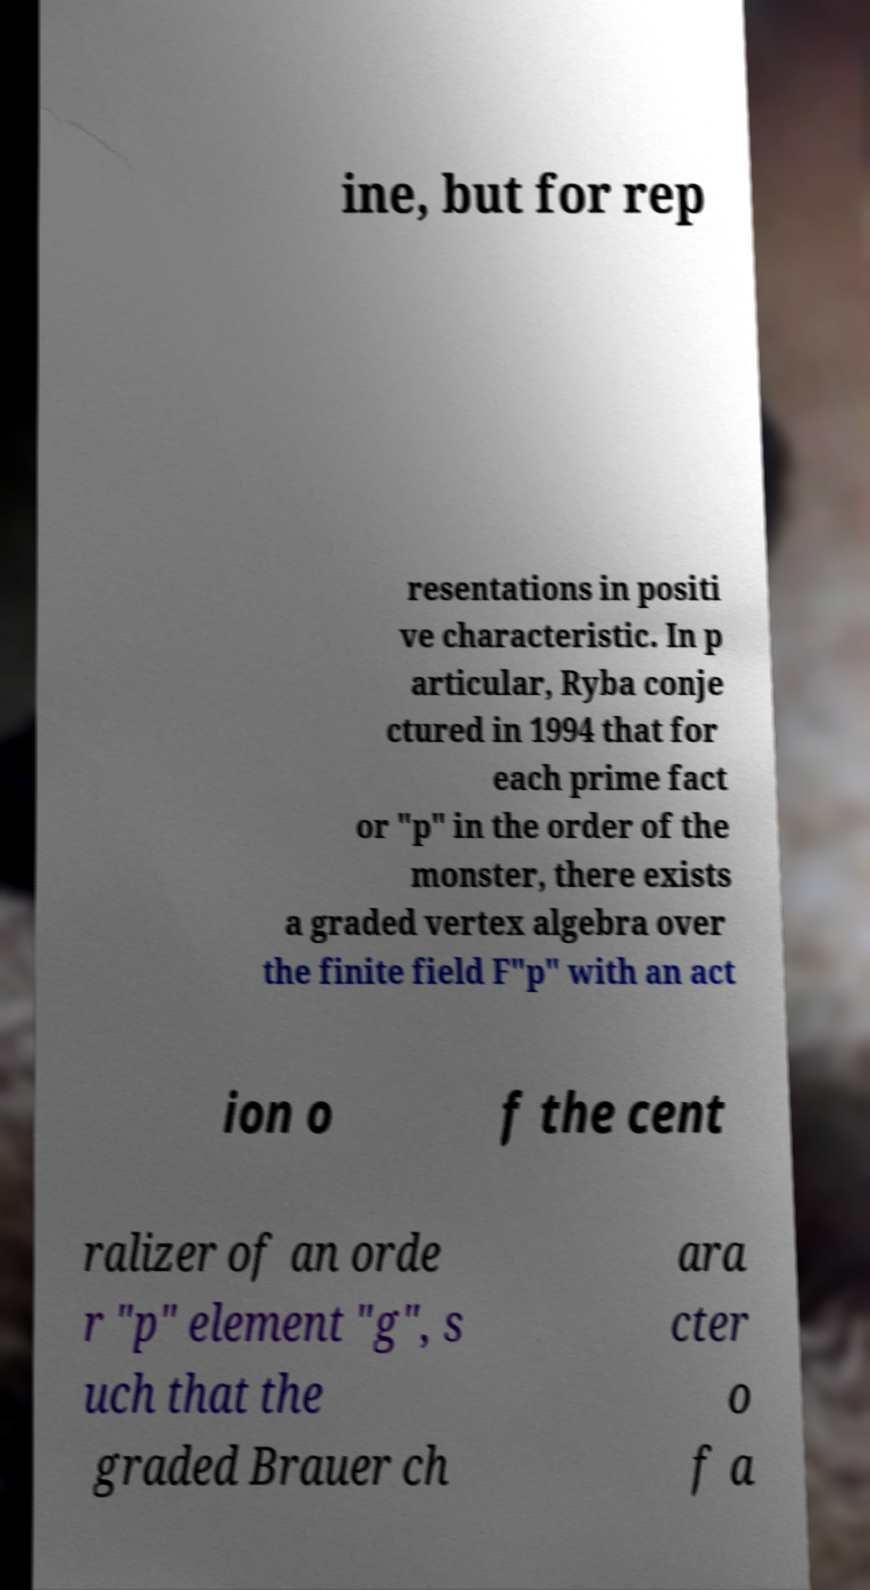I need the written content from this picture converted into text. Can you do that? ine, but for rep resentations in positi ve characteristic. In p articular, Ryba conje ctured in 1994 that for each prime fact or "p" in the order of the monster, there exists a graded vertex algebra over the finite field F"p" with an act ion o f the cent ralizer of an orde r "p" element "g", s uch that the graded Brauer ch ara cter o f a 